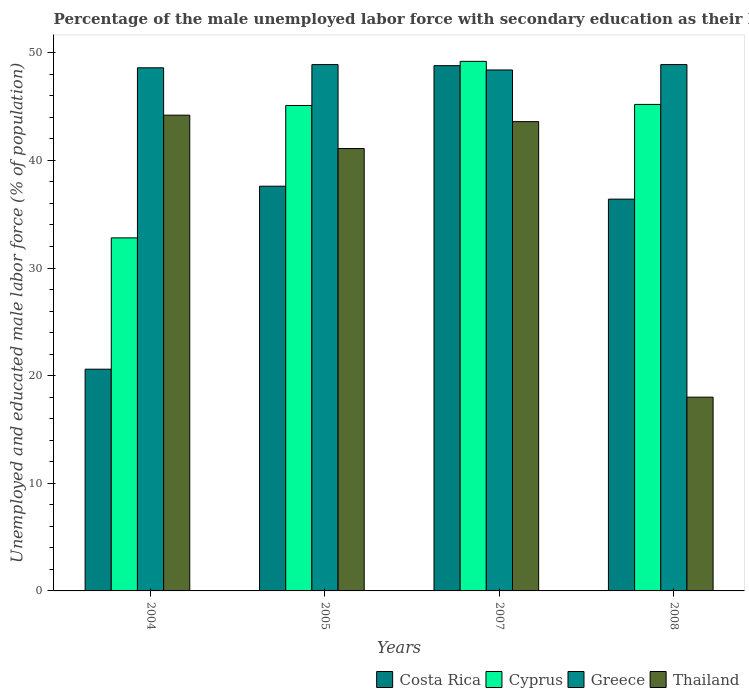Are the number of bars per tick equal to the number of legend labels?
Offer a very short reply. Yes. Are the number of bars on each tick of the X-axis equal?
Ensure brevity in your answer.  Yes. How many bars are there on the 1st tick from the left?
Provide a short and direct response. 4. How many bars are there on the 2nd tick from the right?
Offer a terse response. 4. In how many cases, is the number of bars for a given year not equal to the number of legend labels?
Give a very brief answer. 0. What is the percentage of the unemployed male labor force with secondary education in Cyprus in 2008?
Keep it short and to the point. 45.2. Across all years, what is the maximum percentage of the unemployed male labor force with secondary education in Costa Rica?
Keep it short and to the point. 48.8. Across all years, what is the minimum percentage of the unemployed male labor force with secondary education in Cyprus?
Ensure brevity in your answer.  32.8. In which year was the percentage of the unemployed male labor force with secondary education in Cyprus minimum?
Your answer should be compact. 2004. What is the total percentage of the unemployed male labor force with secondary education in Cyprus in the graph?
Give a very brief answer. 172.3. What is the difference between the percentage of the unemployed male labor force with secondary education in Costa Rica in 2005 and that in 2007?
Offer a terse response. -11.2. What is the difference between the percentage of the unemployed male labor force with secondary education in Greece in 2008 and the percentage of the unemployed male labor force with secondary education in Costa Rica in 2007?
Offer a very short reply. 0.1. What is the average percentage of the unemployed male labor force with secondary education in Greece per year?
Offer a very short reply. 48.7. In how many years, is the percentage of the unemployed male labor force with secondary education in Thailand greater than 16 %?
Your answer should be compact. 4. What is the ratio of the percentage of the unemployed male labor force with secondary education in Greece in 2005 to that in 2007?
Offer a terse response. 1.01. What is the difference between the highest and the second highest percentage of the unemployed male labor force with secondary education in Thailand?
Provide a succinct answer. 0.6. What is the difference between the highest and the lowest percentage of the unemployed male labor force with secondary education in Costa Rica?
Keep it short and to the point. 28.2. Is the sum of the percentage of the unemployed male labor force with secondary education in Thailand in 2004 and 2005 greater than the maximum percentage of the unemployed male labor force with secondary education in Cyprus across all years?
Offer a very short reply. Yes. What does the 2nd bar from the left in 2007 represents?
Your response must be concise. Cyprus. What does the 4th bar from the right in 2007 represents?
Offer a terse response. Costa Rica. Is it the case that in every year, the sum of the percentage of the unemployed male labor force with secondary education in Thailand and percentage of the unemployed male labor force with secondary education in Costa Rica is greater than the percentage of the unemployed male labor force with secondary education in Cyprus?
Your answer should be compact. Yes. Are all the bars in the graph horizontal?
Provide a succinct answer. No. How many years are there in the graph?
Provide a succinct answer. 4. What is the difference between two consecutive major ticks on the Y-axis?
Your response must be concise. 10. Are the values on the major ticks of Y-axis written in scientific E-notation?
Provide a succinct answer. No. Does the graph contain any zero values?
Ensure brevity in your answer.  No. Where does the legend appear in the graph?
Offer a very short reply. Bottom right. How are the legend labels stacked?
Give a very brief answer. Horizontal. What is the title of the graph?
Your answer should be compact. Percentage of the male unemployed labor force with secondary education as their highest grade. What is the label or title of the Y-axis?
Give a very brief answer. Unemployed and educated male labor force (% of population). What is the Unemployed and educated male labor force (% of population) of Costa Rica in 2004?
Provide a succinct answer. 20.6. What is the Unemployed and educated male labor force (% of population) of Cyprus in 2004?
Make the answer very short. 32.8. What is the Unemployed and educated male labor force (% of population) of Greece in 2004?
Provide a short and direct response. 48.6. What is the Unemployed and educated male labor force (% of population) in Thailand in 2004?
Your response must be concise. 44.2. What is the Unemployed and educated male labor force (% of population) of Costa Rica in 2005?
Make the answer very short. 37.6. What is the Unemployed and educated male labor force (% of population) in Cyprus in 2005?
Offer a very short reply. 45.1. What is the Unemployed and educated male labor force (% of population) of Greece in 2005?
Offer a terse response. 48.9. What is the Unemployed and educated male labor force (% of population) in Thailand in 2005?
Provide a succinct answer. 41.1. What is the Unemployed and educated male labor force (% of population) in Costa Rica in 2007?
Ensure brevity in your answer.  48.8. What is the Unemployed and educated male labor force (% of population) in Cyprus in 2007?
Your response must be concise. 49.2. What is the Unemployed and educated male labor force (% of population) of Greece in 2007?
Your answer should be very brief. 48.4. What is the Unemployed and educated male labor force (% of population) of Thailand in 2007?
Offer a very short reply. 43.6. What is the Unemployed and educated male labor force (% of population) in Costa Rica in 2008?
Provide a short and direct response. 36.4. What is the Unemployed and educated male labor force (% of population) of Cyprus in 2008?
Ensure brevity in your answer.  45.2. What is the Unemployed and educated male labor force (% of population) of Greece in 2008?
Provide a short and direct response. 48.9. What is the Unemployed and educated male labor force (% of population) in Thailand in 2008?
Keep it short and to the point. 18. Across all years, what is the maximum Unemployed and educated male labor force (% of population) in Costa Rica?
Give a very brief answer. 48.8. Across all years, what is the maximum Unemployed and educated male labor force (% of population) of Cyprus?
Ensure brevity in your answer.  49.2. Across all years, what is the maximum Unemployed and educated male labor force (% of population) in Greece?
Provide a succinct answer. 48.9. Across all years, what is the maximum Unemployed and educated male labor force (% of population) in Thailand?
Make the answer very short. 44.2. Across all years, what is the minimum Unemployed and educated male labor force (% of population) in Costa Rica?
Ensure brevity in your answer.  20.6. Across all years, what is the minimum Unemployed and educated male labor force (% of population) of Cyprus?
Keep it short and to the point. 32.8. Across all years, what is the minimum Unemployed and educated male labor force (% of population) in Greece?
Provide a succinct answer. 48.4. Across all years, what is the minimum Unemployed and educated male labor force (% of population) of Thailand?
Provide a succinct answer. 18. What is the total Unemployed and educated male labor force (% of population) of Costa Rica in the graph?
Keep it short and to the point. 143.4. What is the total Unemployed and educated male labor force (% of population) of Cyprus in the graph?
Your answer should be very brief. 172.3. What is the total Unemployed and educated male labor force (% of population) in Greece in the graph?
Ensure brevity in your answer.  194.8. What is the total Unemployed and educated male labor force (% of population) in Thailand in the graph?
Make the answer very short. 146.9. What is the difference between the Unemployed and educated male labor force (% of population) of Cyprus in 2004 and that in 2005?
Provide a succinct answer. -12.3. What is the difference between the Unemployed and educated male labor force (% of population) of Thailand in 2004 and that in 2005?
Offer a very short reply. 3.1. What is the difference between the Unemployed and educated male labor force (% of population) of Costa Rica in 2004 and that in 2007?
Provide a short and direct response. -28.2. What is the difference between the Unemployed and educated male labor force (% of population) in Cyprus in 2004 and that in 2007?
Provide a short and direct response. -16.4. What is the difference between the Unemployed and educated male labor force (% of population) of Costa Rica in 2004 and that in 2008?
Your answer should be compact. -15.8. What is the difference between the Unemployed and educated male labor force (% of population) in Cyprus in 2004 and that in 2008?
Give a very brief answer. -12.4. What is the difference between the Unemployed and educated male labor force (% of population) of Greece in 2004 and that in 2008?
Give a very brief answer. -0.3. What is the difference between the Unemployed and educated male labor force (% of population) of Thailand in 2004 and that in 2008?
Offer a terse response. 26.2. What is the difference between the Unemployed and educated male labor force (% of population) of Costa Rica in 2005 and that in 2007?
Keep it short and to the point. -11.2. What is the difference between the Unemployed and educated male labor force (% of population) in Cyprus in 2005 and that in 2007?
Your response must be concise. -4.1. What is the difference between the Unemployed and educated male labor force (% of population) of Costa Rica in 2005 and that in 2008?
Offer a very short reply. 1.2. What is the difference between the Unemployed and educated male labor force (% of population) in Thailand in 2005 and that in 2008?
Offer a very short reply. 23.1. What is the difference between the Unemployed and educated male labor force (% of population) in Cyprus in 2007 and that in 2008?
Provide a succinct answer. 4. What is the difference between the Unemployed and educated male labor force (% of population) in Thailand in 2007 and that in 2008?
Provide a short and direct response. 25.6. What is the difference between the Unemployed and educated male labor force (% of population) in Costa Rica in 2004 and the Unemployed and educated male labor force (% of population) in Cyprus in 2005?
Offer a terse response. -24.5. What is the difference between the Unemployed and educated male labor force (% of population) in Costa Rica in 2004 and the Unemployed and educated male labor force (% of population) in Greece in 2005?
Give a very brief answer. -28.3. What is the difference between the Unemployed and educated male labor force (% of population) of Costa Rica in 2004 and the Unemployed and educated male labor force (% of population) of Thailand in 2005?
Give a very brief answer. -20.5. What is the difference between the Unemployed and educated male labor force (% of population) in Cyprus in 2004 and the Unemployed and educated male labor force (% of population) in Greece in 2005?
Provide a short and direct response. -16.1. What is the difference between the Unemployed and educated male labor force (% of population) of Greece in 2004 and the Unemployed and educated male labor force (% of population) of Thailand in 2005?
Ensure brevity in your answer.  7.5. What is the difference between the Unemployed and educated male labor force (% of population) of Costa Rica in 2004 and the Unemployed and educated male labor force (% of population) of Cyprus in 2007?
Offer a very short reply. -28.6. What is the difference between the Unemployed and educated male labor force (% of population) in Costa Rica in 2004 and the Unemployed and educated male labor force (% of population) in Greece in 2007?
Offer a terse response. -27.8. What is the difference between the Unemployed and educated male labor force (% of population) in Costa Rica in 2004 and the Unemployed and educated male labor force (% of population) in Thailand in 2007?
Provide a short and direct response. -23. What is the difference between the Unemployed and educated male labor force (% of population) in Cyprus in 2004 and the Unemployed and educated male labor force (% of population) in Greece in 2007?
Offer a very short reply. -15.6. What is the difference between the Unemployed and educated male labor force (% of population) in Greece in 2004 and the Unemployed and educated male labor force (% of population) in Thailand in 2007?
Make the answer very short. 5. What is the difference between the Unemployed and educated male labor force (% of population) in Costa Rica in 2004 and the Unemployed and educated male labor force (% of population) in Cyprus in 2008?
Ensure brevity in your answer.  -24.6. What is the difference between the Unemployed and educated male labor force (% of population) in Costa Rica in 2004 and the Unemployed and educated male labor force (% of population) in Greece in 2008?
Your answer should be very brief. -28.3. What is the difference between the Unemployed and educated male labor force (% of population) in Cyprus in 2004 and the Unemployed and educated male labor force (% of population) in Greece in 2008?
Ensure brevity in your answer.  -16.1. What is the difference between the Unemployed and educated male labor force (% of population) of Cyprus in 2004 and the Unemployed and educated male labor force (% of population) of Thailand in 2008?
Keep it short and to the point. 14.8. What is the difference between the Unemployed and educated male labor force (% of population) of Greece in 2004 and the Unemployed and educated male labor force (% of population) of Thailand in 2008?
Ensure brevity in your answer.  30.6. What is the difference between the Unemployed and educated male labor force (% of population) of Costa Rica in 2005 and the Unemployed and educated male labor force (% of population) of Cyprus in 2007?
Make the answer very short. -11.6. What is the difference between the Unemployed and educated male labor force (% of population) of Costa Rica in 2005 and the Unemployed and educated male labor force (% of population) of Greece in 2007?
Your answer should be very brief. -10.8. What is the difference between the Unemployed and educated male labor force (% of population) in Costa Rica in 2005 and the Unemployed and educated male labor force (% of population) in Cyprus in 2008?
Keep it short and to the point. -7.6. What is the difference between the Unemployed and educated male labor force (% of population) of Costa Rica in 2005 and the Unemployed and educated male labor force (% of population) of Greece in 2008?
Keep it short and to the point. -11.3. What is the difference between the Unemployed and educated male labor force (% of population) of Costa Rica in 2005 and the Unemployed and educated male labor force (% of population) of Thailand in 2008?
Your response must be concise. 19.6. What is the difference between the Unemployed and educated male labor force (% of population) of Cyprus in 2005 and the Unemployed and educated male labor force (% of population) of Greece in 2008?
Give a very brief answer. -3.8. What is the difference between the Unemployed and educated male labor force (% of population) of Cyprus in 2005 and the Unemployed and educated male labor force (% of population) of Thailand in 2008?
Your answer should be very brief. 27.1. What is the difference between the Unemployed and educated male labor force (% of population) of Greece in 2005 and the Unemployed and educated male labor force (% of population) of Thailand in 2008?
Ensure brevity in your answer.  30.9. What is the difference between the Unemployed and educated male labor force (% of population) of Costa Rica in 2007 and the Unemployed and educated male labor force (% of population) of Greece in 2008?
Give a very brief answer. -0.1. What is the difference between the Unemployed and educated male labor force (% of population) in Costa Rica in 2007 and the Unemployed and educated male labor force (% of population) in Thailand in 2008?
Your answer should be very brief. 30.8. What is the difference between the Unemployed and educated male labor force (% of population) of Cyprus in 2007 and the Unemployed and educated male labor force (% of population) of Thailand in 2008?
Offer a terse response. 31.2. What is the difference between the Unemployed and educated male labor force (% of population) in Greece in 2007 and the Unemployed and educated male labor force (% of population) in Thailand in 2008?
Provide a short and direct response. 30.4. What is the average Unemployed and educated male labor force (% of population) of Costa Rica per year?
Ensure brevity in your answer.  35.85. What is the average Unemployed and educated male labor force (% of population) in Cyprus per year?
Make the answer very short. 43.08. What is the average Unemployed and educated male labor force (% of population) in Greece per year?
Offer a very short reply. 48.7. What is the average Unemployed and educated male labor force (% of population) of Thailand per year?
Your response must be concise. 36.73. In the year 2004, what is the difference between the Unemployed and educated male labor force (% of population) in Costa Rica and Unemployed and educated male labor force (% of population) in Cyprus?
Provide a short and direct response. -12.2. In the year 2004, what is the difference between the Unemployed and educated male labor force (% of population) in Costa Rica and Unemployed and educated male labor force (% of population) in Thailand?
Provide a succinct answer. -23.6. In the year 2004, what is the difference between the Unemployed and educated male labor force (% of population) in Cyprus and Unemployed and educated male labor force (% of population) in Greece?
Make the answer very short. -15.8. In the year 2005, what is the difference between the Unemployed and educated male labor force (% of population) in Costa Rica and Unemployed and educated male labor force (% of population) in Greece?
Make the answer very short. -11.3. In the year 2007, what is the difference between the Unemployed and educated male labor force (% of population) in Costa Rica and Unemployed and educated male labor force (% of population) in Greece?
Provide a short and direct response. 0.4. In the year 2007, what is the difference between the Unemployed and educated male labor force (% of population) in Costa Rica and Unemployed and educated male labor force (% of population) in Thailand?
Your answer should be compact. 5.2. In the year 2007, what is the difference between the Unemployed and educated male labor force (% of population) of Cyprus and Unemployed and educated male labor force (% of population) of Greece?
Offer a very short reply. 0.8. In the year 2007, what is the difference between the Unemployed and educated male labor force (% of population) of Cyprus and Unemployed and educated male labor force (% of population) of Thailand?
Your response must be concise. 5.6. In the year 2008, what is the difference between the Unemployed and educated male labor force (% of population) of Cyprus and Unemployed and educated male labor force (% of population) of Greece?
Your response must be concise. -3.7. In the year 2008, what is the difference between the Unemployed and educated male labor force (% of population) in Cyprus and Unemployed and educated male labor force (% of population) in Thailand?
Keep it short and to the point. 27.2. In the year 2008, what is the difference between the Unemployed and educated male labor force (% of population) in Greece and Unemployed and educated male labor force (% of population) in Thailand?
Your answer should be very brief. 30.9. What is the ratio of the Unemployed and educated male labor force (% of population) of Costa Rica in 2004 to that in 2005?
Offer a terse response. 0.55. What is the ratio of the Unemployed and educated male labor force (% of population) of Cyprus in 2004 to that in 2005?
Provide a succinct answer. 0.73. What is the ratio of the Unemployed and educated male labor force (% of population) in Greece in 2004 to that in 2005?
Provide a short and direct response. 0.99. What is the ratio of the Unemployed and educated male labor force (% of population) of Thailand in 2004 to that in 2005?
Your answer should be compact. 1.08. What is the ratio of the Unemployed and educated male labor force (% of population) in Costa Rica in 2004 to that in 2007?
Make the answer very short. 0.42. What is the ratio of the Unemployed and educated male labor force (% of population) in Thailand in 2004 to that in 2007?
Make the answer very short. 1.01. What is the ratio of the Unemployed and educated male labor force (% of population) of Costa Rica in 2004 to that in 2008?
Offer a terse response. 0.57. What is the ratio of the Unemployed and educated male labor force (% of population) in Cyprus in 2004 to that in 2008?
Your answer should be very brief. 0.73. What is the ratio of the Unemployed and educated male labor force (% of population) of Thailand in 2004 to that in 2008?
Your answer should be very brief. 2.46. What is the ratio of the Unemployed and educated male labor force (% of population) of Costa Rica in 2005 to that in 2007?
Your response must be concise. 0.77. What is the ratio of the Unemployed and educated male labor force (% of population) in Greece in 2005 to that in 2007?
Offer a very short reply. 1.01. What is the ratio of the Unemployed and educated male labor force (% of population) of Thailand in 2005 to that in 2007?
Keep it short and to the point. 0.94. What is the ratio of the Unemployed and educated male labor force (% of population) of Costa Rica in 2005 to that in 2008?
Ensure brevity in your answer.  1.03. What is the ratio of the Unemployed and educated male labor force (% of population) in Thailand in 2005 to that in 2008?
Keep it short and to the point. 2.28. What is the ratio of the Unemployed and educated male labor force (% of population) in Costa Rica in 2007 to that in 2008?
Ensure brevity in your answer.  1.34. What is the ratio of the Unemployed and educated male labor force (% of population) of Cyprus in 2007 to that in 2008?
Your answer should be compact. 1.09. What is the ratio of the Unemployed and educated male labor force (% of population) of Greece in 2007 to that in 2008?
Keep it short and to the point. 0.99. What is the ratio of the Unemployed and educated male labor force (% of population) of Thailand in 2007 to that in 2008?
Provide a short and direct response. 2.42. What is the difference between the highest and the second highest Unemployed and educated male labor force (% of population) in Cyprus?
Offer a very short reply. 4. What is the difference between the highest and the second highest Unemployed and educated male labor force (% of population) of Greece?
Offer a terse response. 0. What is the difference between the highest and the lowest Unemployed and educated male labor force (% of population) of Costa Rica?
Offer a very short reply. 28.2. What is the difference between the highest and the lowest Unemployed and educated male labor force (% of population) of Greece?
Provide a short and direct response. 0.5. What is the difference between the highest and the lowest Unemployed and educated male labor force (% of population) in Thailand?
Offer a very short reply. 26.2. 